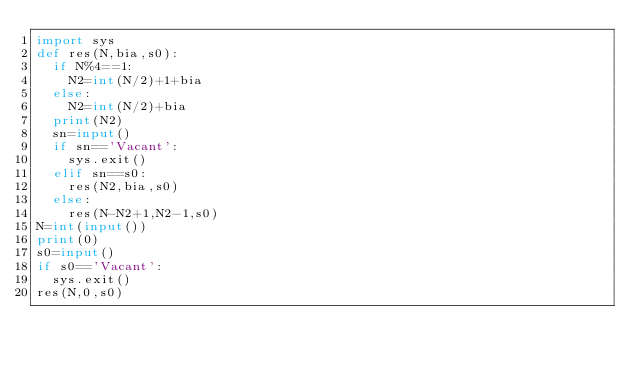Convert code to text. <code><loc_0><loc_0><loc_500><loc_500><_Python_>import sys
def res(N,bia,s0):
  if N%4==1:
    N2=int(N/2)+1+bia
  else:
    N2=int(N/2)+bia
  print(N2)
  sn=input()
  if sn=='Vacant':
    sys.exit()
  elif sn==s0:
    res(N2,bia,s0)
  else:
    res(N-N2+1,N2-1,s0)
N=int(input())
print(0)
s0=input()
if s0=='Vacant':
  sys.exit()
res(N,0,s0)</code> 